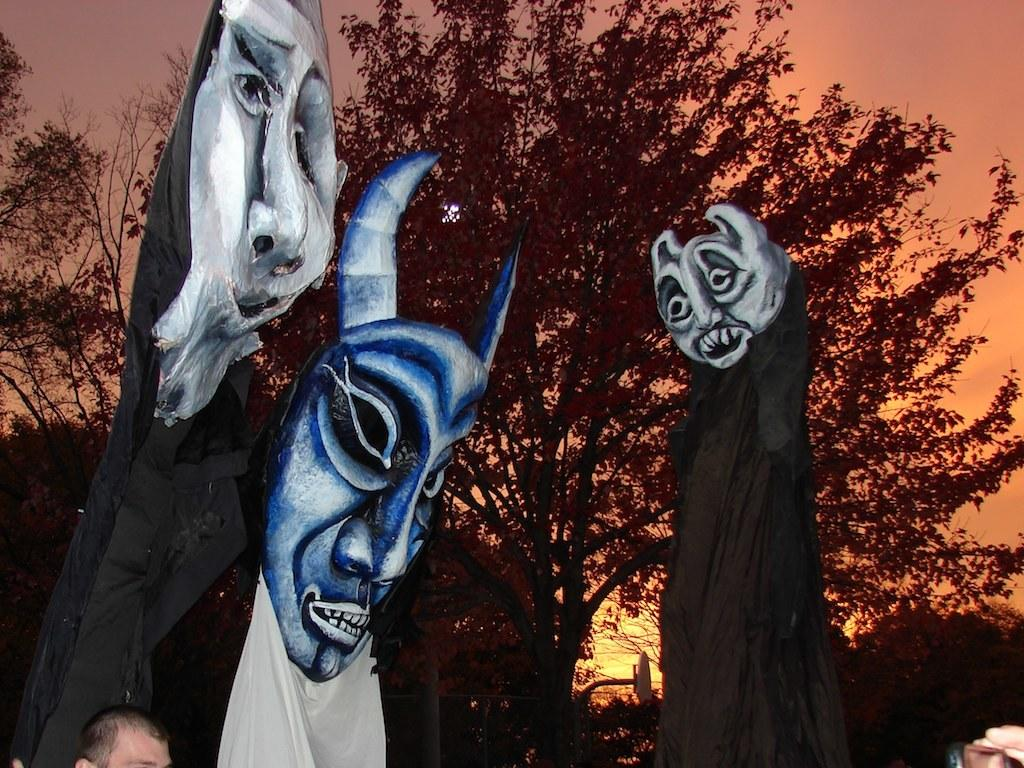Where was the picture taken? The picture was clicked outside. What can be seen in the foreground of the image? There are clothes and masks in the foreground, along with some persons. What is visible in the background of the image? The sky, trees, and other unspecified items can be seen in the background. What type of root can be seen growing in the image? There is no root visible in the image; it is focused on clothes, masks, persons, and the background. 